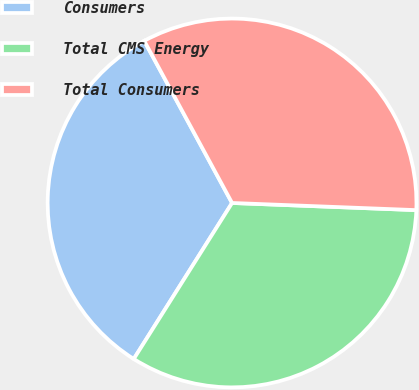Convert chart to OTSL. <chart><loc_0><loc_0><loc_500><loc_500><pie_chart><fcel>Consumers<fcel>Total CMS Energy<fcel>Total Consumers<nl><fcel>33.15%<fcel>33.33%<fcel>33.52%<nl></chart> 